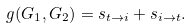<formula> <loc_0><loc_0><loc_500><loc_500>g ( G _ { 1 } , G _ { 2 } ) = s _ { t \rightarrow i } + s _ { i \rightarrow t } .</formula> 